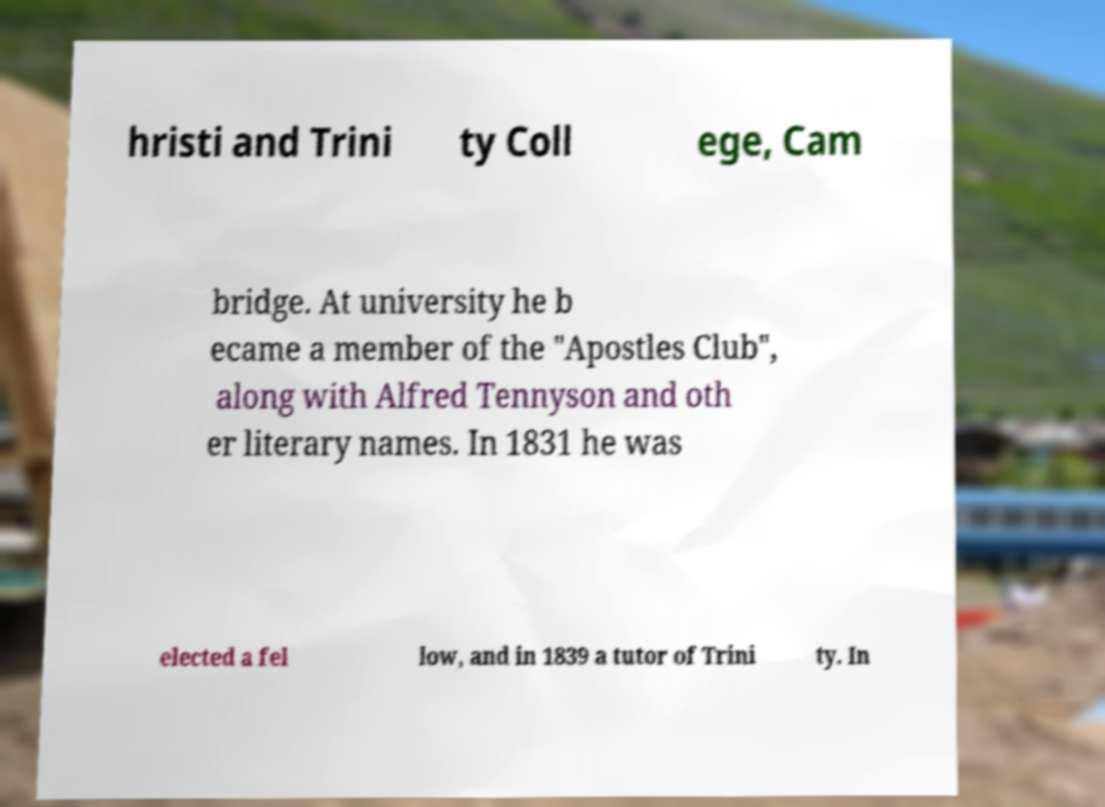I need the written content from this picture converted into text. Can you do that? hristi and Trini ty Coll ege, Cam bridge. At university he b ecame a member of the "Apostles Club", along with Alfred Tennyson and oth er literary names. In 1831 he was elected a fel low, and in 1839 a tutor of Trini ty. In 